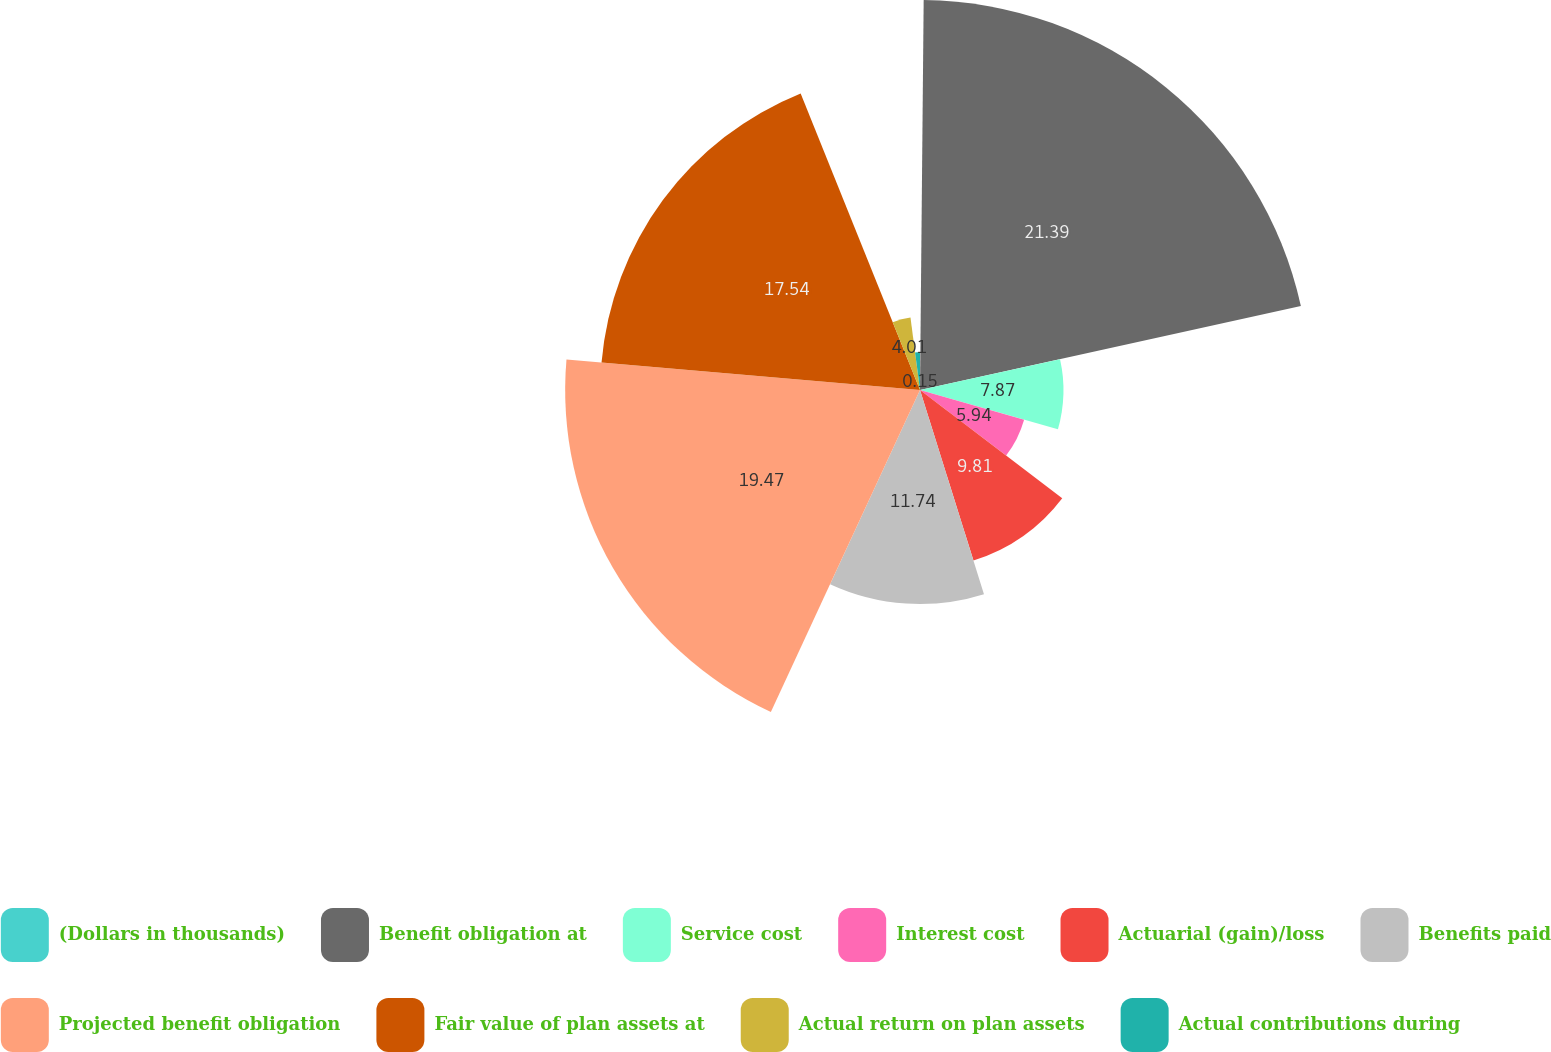Convert chart to OTSL. <chart><loc_0><loc_0><loc_500><loc_500><pie_chart><fcel>(Dollars in thousands)<fcel>Benefit obligation at<fcel>Service cost<fcel>Interest cost<fcel>Actuarial (gain)/loss<fcel>Benefits paid<fcel>Projected benefit obligation<fcel>Fair value of plan assets at<fcel>Actual return on plan assets<fcel>Actual contributions during<nl><fcel>0.15%<fcel>21.4%<fcel>7.87%<fcel>5.94%<fcel>9.81%<fcel>11.74%<fcel>19.47%<fcel>17.54%<fcel>4.01%<fcel>2.08%<nl></chart> 